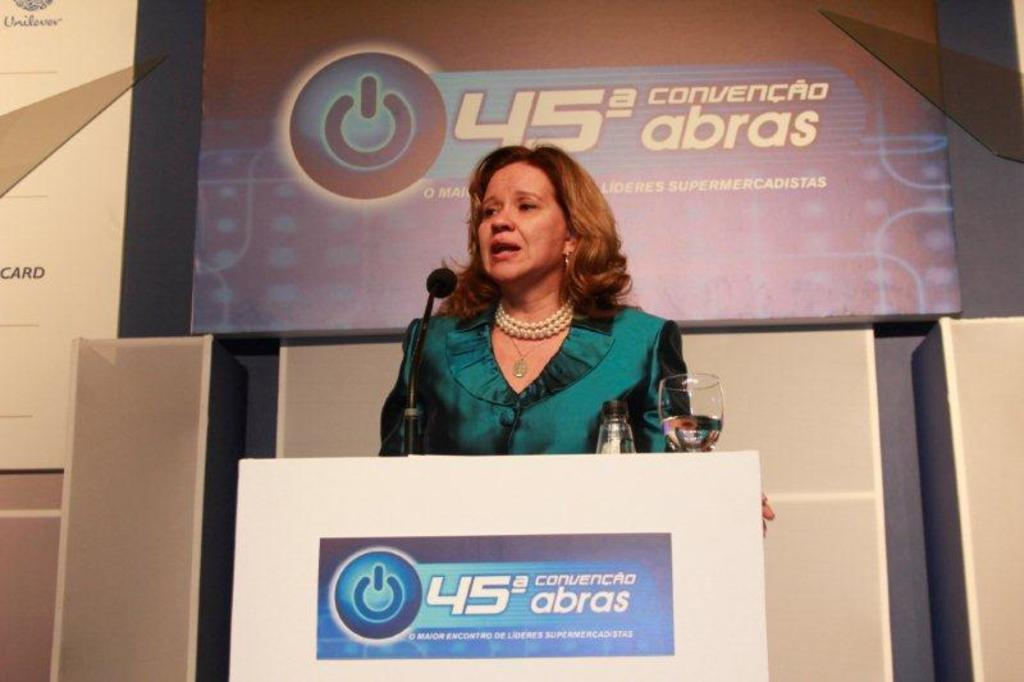Who is the main subject in the image? There is a woman in the image. What is the woman doing in the image? The woman is standing in front of a podium. What can be seen in the background of the image? There is a board with text in the background of the image. How many geese are present in the garden behind the woman in the image? There are no geese or garden present in the image; it only features a woman standing in front of a podium with a board with text in the background. 